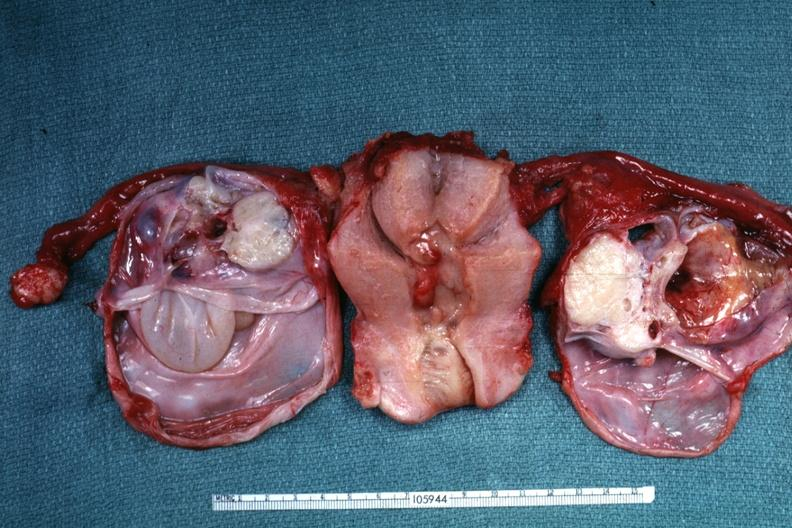what have been cut to show multiloculated nature of tumor masses?
Answer the question using a single word or phrase. Same as except ovaries 